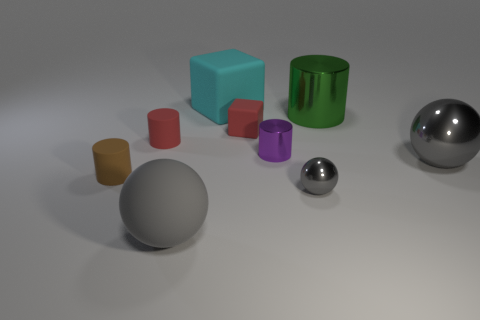Subtract all gray spheres. How many were subtracted if there are1gray spheres left? 2 Subtract 2 cylinders. How many cylinders are left? 2 Add 1 big green objects. How many objects exist? 10 Subtract all brown cylinders. How many cylinders are left? 3 Subtract all tiny shiny cylinders. How many cylinders are left? 3 Subtract all yellow cylinders. Subtract all cyan cubes. How many cylinders are left? 4 Subtract all blocks. How many objects are left? 7 Add 5 rubber cylinders. How many rubber cylinders exist? 7 Subtract 0 purple balls. How many objects are left? 9 Subtract all small brown matte things. Subtract all blue metal spheres. How many objects are left? 8 